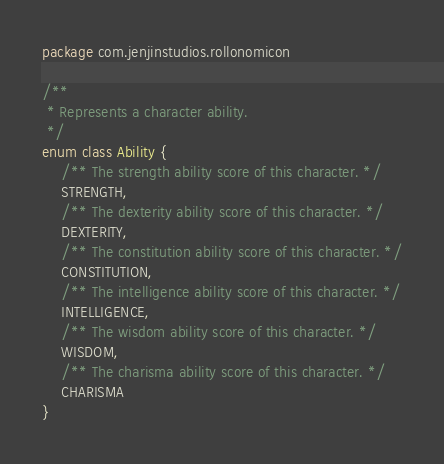<code> <loc_0><loc_0><loc_500><loc_500><_Kotlin_>package com.jenjinstudios.rollonomicon

/**
 * Represents a character ability.
 */
enum class Ability {
    /** The strength ability score of this character. */
    STRENGTH,
    /** The dexterity ability score of this character. */
    DEXTERITY,
    /** The constitution ability score of this character. */
    CONSTITUTION,
    /** The intelligence ability score of this character. */
    INTELLIGENCE,
    /** The wisdom ability score of this character. */
    WISDOM,
    /** The charisma ability score of this character. */
    CHARISMA
}</code> 